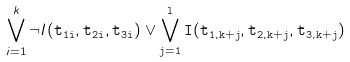Convert formula to latex. <formula><loc_0><loc_0><loc_500><loc_500>\bigvee _ { i = 1 } ^ { k } \neg I ( \tt t _ { 1 i } , \tt t _ { 2 i } , \tt t _ { 3 i } ) \vee \bigvee _ { j = 1 } ^ { l } I ( \tt t _ { 1 , k + j } , \tt t _ { 2 , k + j } , \tt t _ { 3 , k + j } )</formula> 